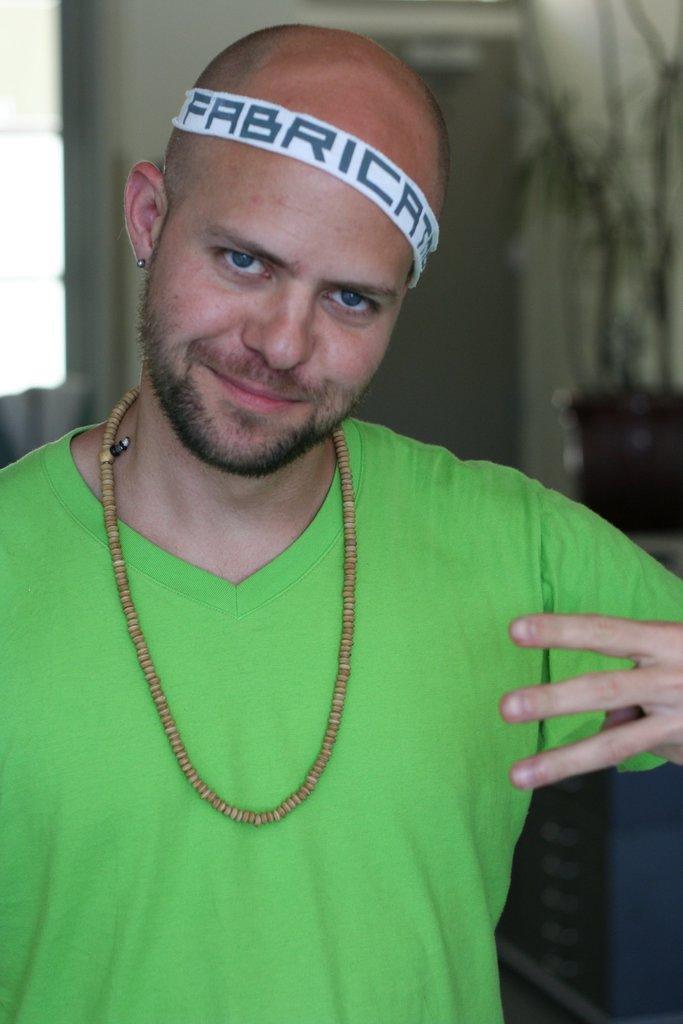Could you give a brief overview of what you see in this image? In this image a man wearing green t-shirt is standing. He is wearing a headband. The background is blurry. 